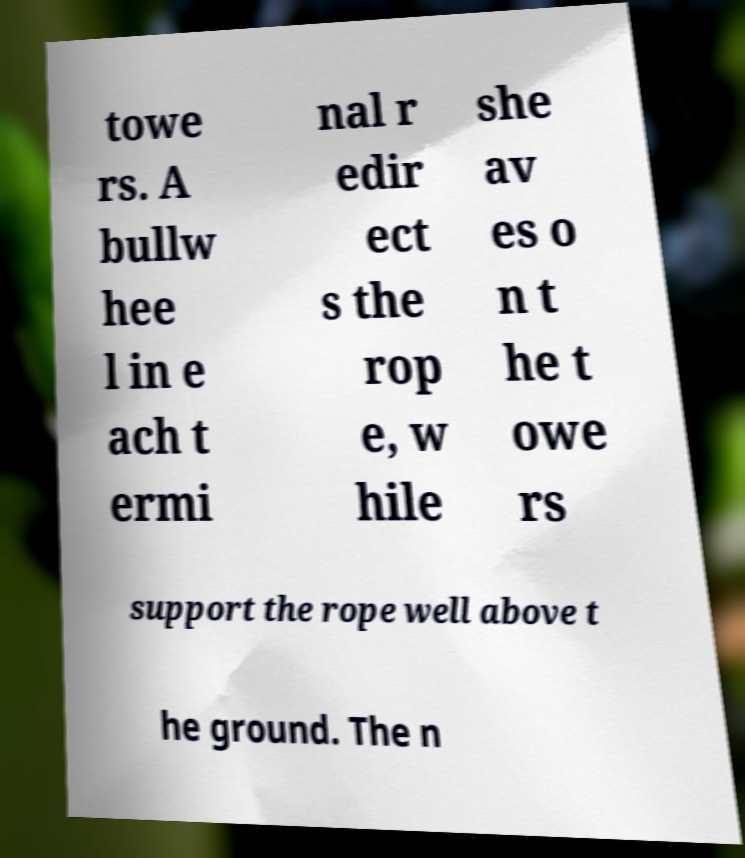I need the written content from this picture converted into text. Can you do that? towe rs. A bullw hee l in e ach t ermi nal r edir ect s the rop e, w hile she av es o n t he t owe rs support the rope well above t he ground. The n 